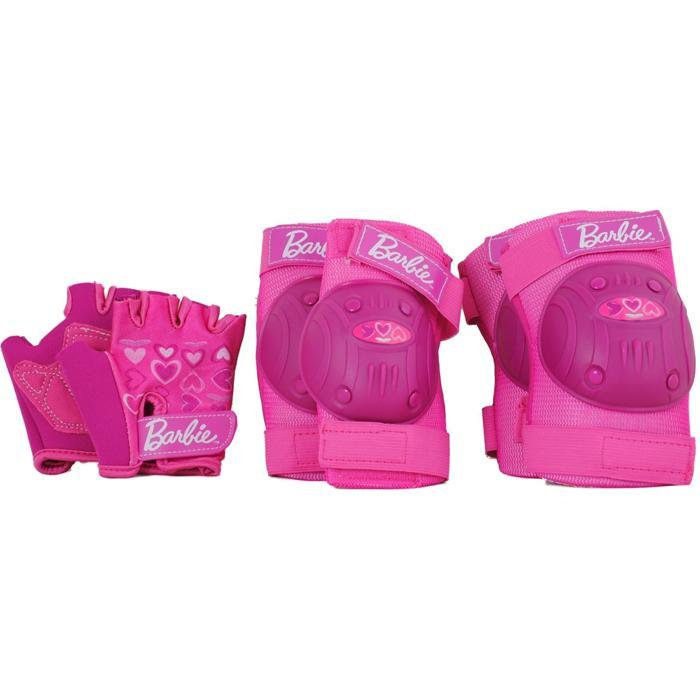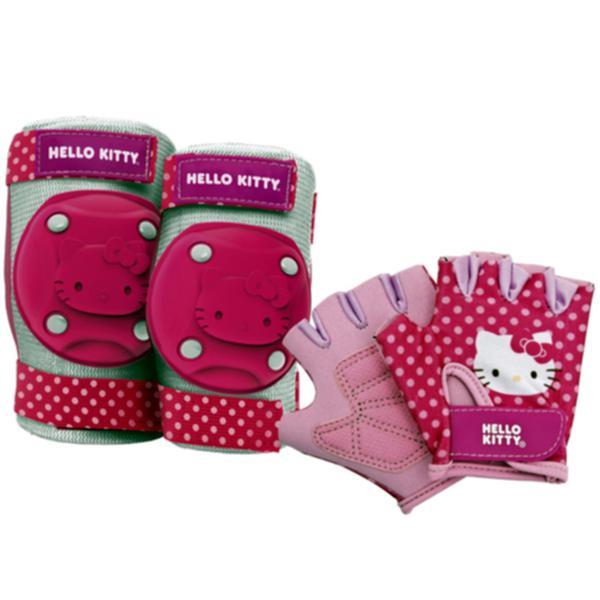The first image is the image on the left, the second image is the image on the right. Evaluate the accuracy of this statement regarding the images: "One image features a pair of legs wearing knee pads, and the other image includes a white knee pad.". Is it true? Answer yes or no. No. 